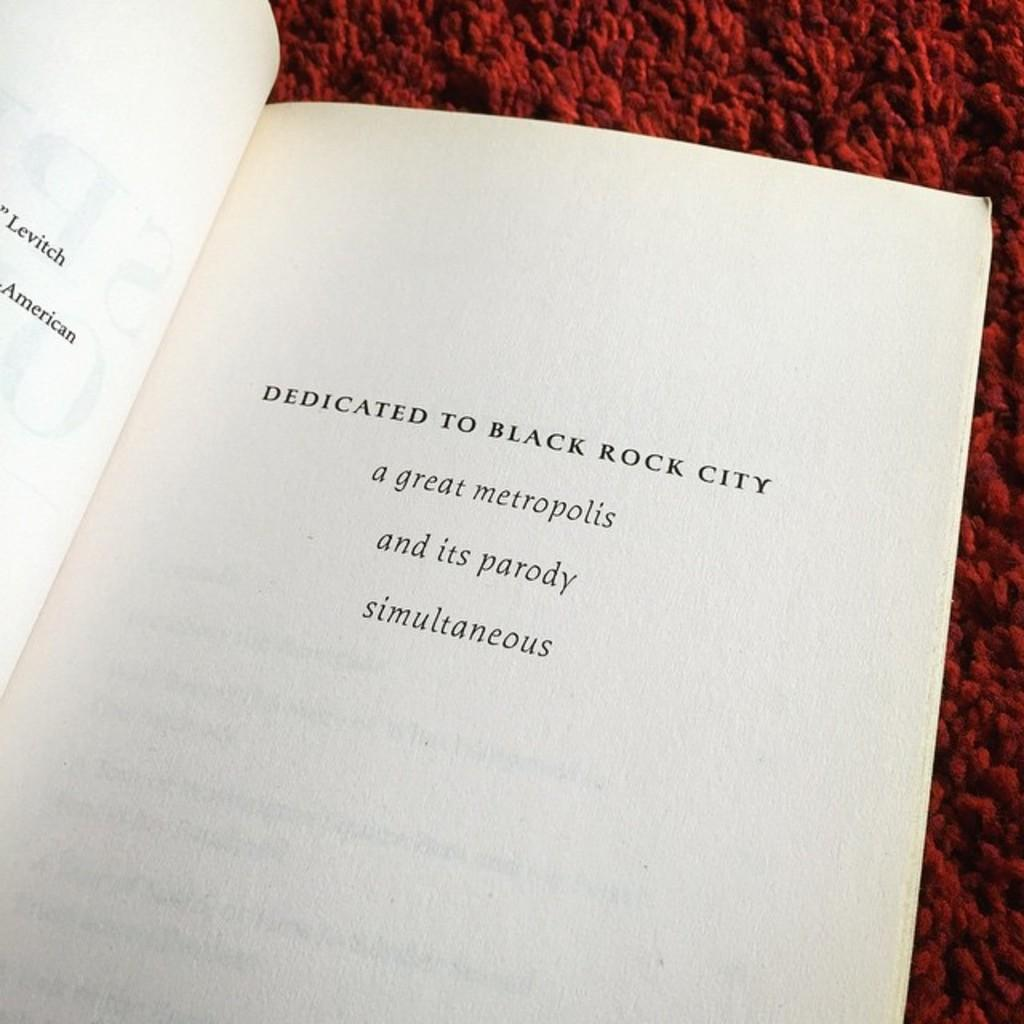<image>
Render a clear and concise summary of the photo. opened book that is dedicated to black rock city 